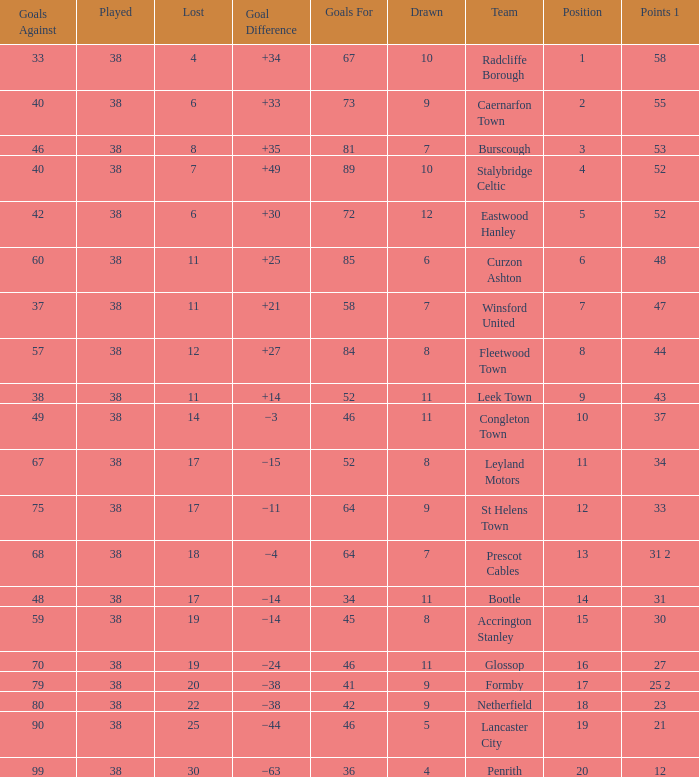Could you parse the entire table? {'header': ['Goals Against', 'Played', 'Lost', 'Goal Difference', 'Goals For', 'Drawn', 'Team', 'Position', 'Points 1'], 'rows': [['33', '38', '4', '+34', '67', '10', 'Radcliffe Borough', '1', '58'], ['40', '38', '6', '+33', '73', '9', 'Caernarfon Town', '2', '55'], ['46', '38', '8', '+35', '81', '7', 'Burscough', '3', '53'], ['40', '38', '7', '+49', '89', '10', 'Stalybridge Celtic', '4', '52'], ['42', '38', '6', '+30', '72', '12', 'Eastwood Hanley', '5', '52'], ['60', '38', '11', '+25', '85', '6', 'Curzon Ashton', '6', '48'], ['37', '38', '11', '+21', '58', '7', 'Winsford United', '7', '47'], ['57', '38', '12', '+27', '84', '8', 'Fleetwood Town', '8', '44'], ['38', '38', '11', '+14', '52', '11', 'Leek Town', '9', '43'], ['49', '38', '14', '−3', '46', '11', 'Congleton Town', '10', '37'], ['67', '38', '17', '−15', '52', '8', 'Leyland Motors', '11', '34'], ['75', '38', '17', '−11', '64', '9', 'St Helens Town', '12', '33'], ['68', '38', '18', '−4', '64', '7', 'Prescot Cables', '13', '31 2'], ['48', '38', '17', '−14', '34', '11', 'Bootle', '14', '31'], ['59', '38', '19', '−14', '45', '8', 'Accrington Stanley', '15', '30'], ['70', '38', '19', '−24', '46', '11', 'Glossop', '16', '27'], ['79', '38', '20', '−38', '41', '9', 'Formby', '17', '25 2'], ['80', '38', '22', '−38', '42', '9', 'Netherfield', '18', '23'], ['90', '38', '25', '−44', '46', '5', 'Lancaster City', '19', '21'], ['99', '38', '30', '−63', '36', '4', 'Penrith', '20', '12']]} WHAT POINTS 1 HAD A 22 LOST? 23.0. 